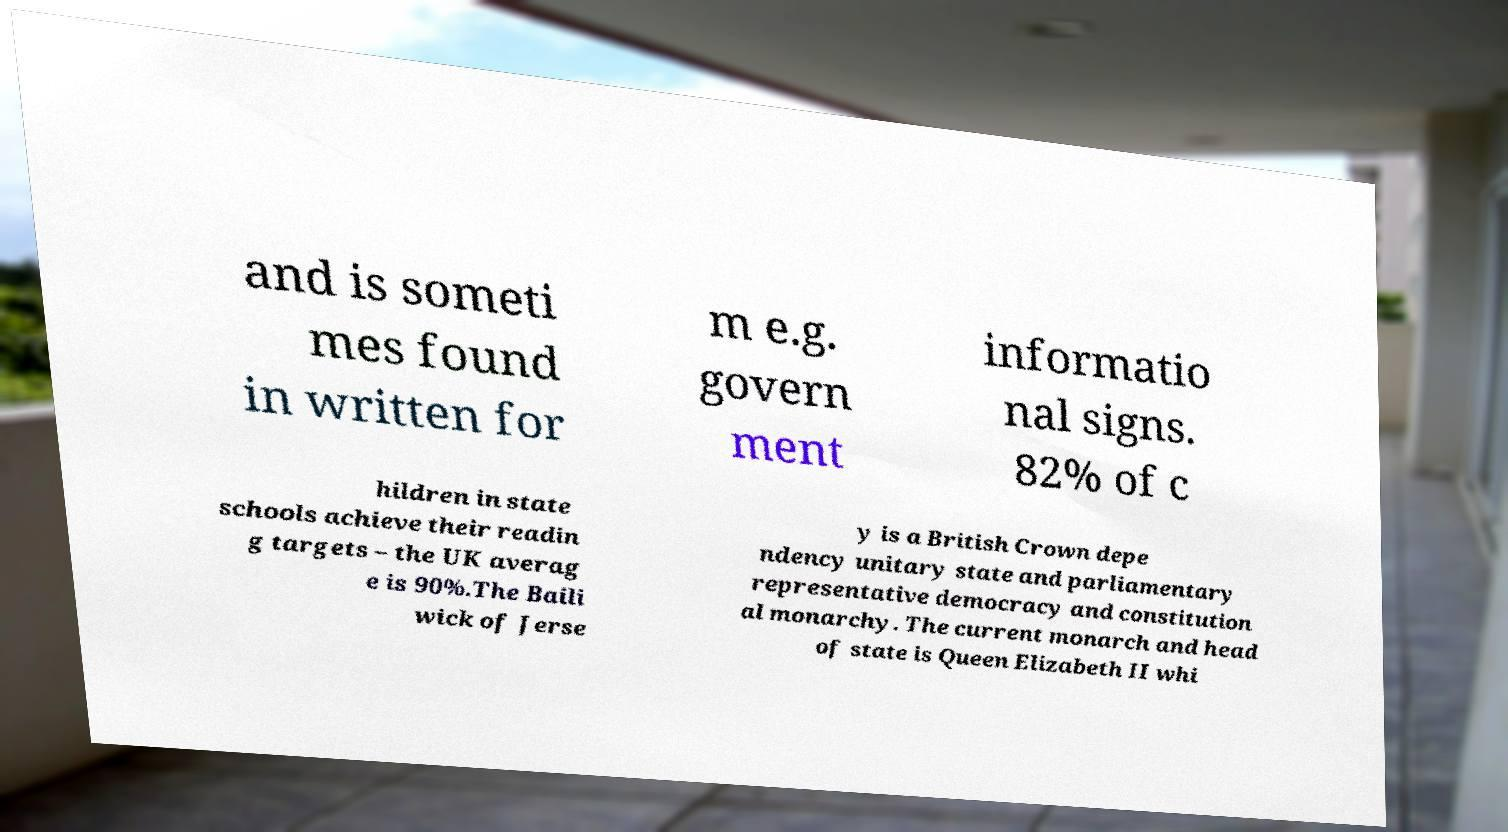Please read and relay the text visible in this image. What does it say? and is someti mes found in written for m e.g. govern ment informatio nal signs. 82% of c hildren in state schools achieve their readin g targets – the UK averag e is 90%.The Baili wick of Jerse y is a British Crown depe ndency unitary state and parliamentary representative democracy and constitution al monarchy. The current monarch and head of state is Queen Elizabeth II whi 